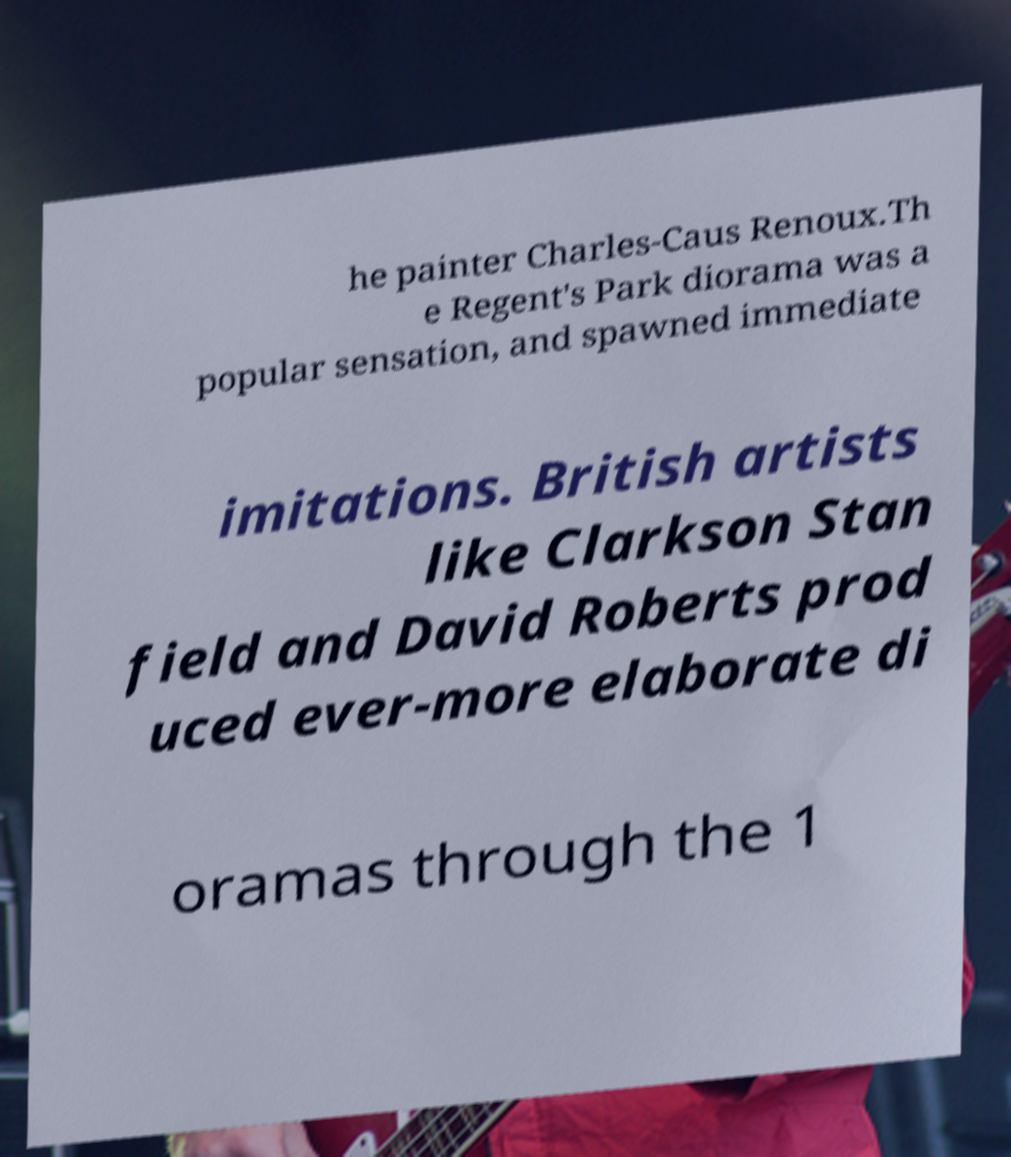I need the written content from this picture converted into text. Can you do that? he painter Charles-Caus Renoux.Th e Regent's Park diorama was a popular sensation, and spawned immediate imitations. British artists like Clarkson Stan field and David Roberts prod uced ever-more elaborate di oramas through the 1 